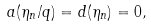<formula> <loc_0><loc_0><loc_500><loc_500>a ( \eta _ { n } / q ) = d ( \eta _ { n } ) = 0 ,</formula> 